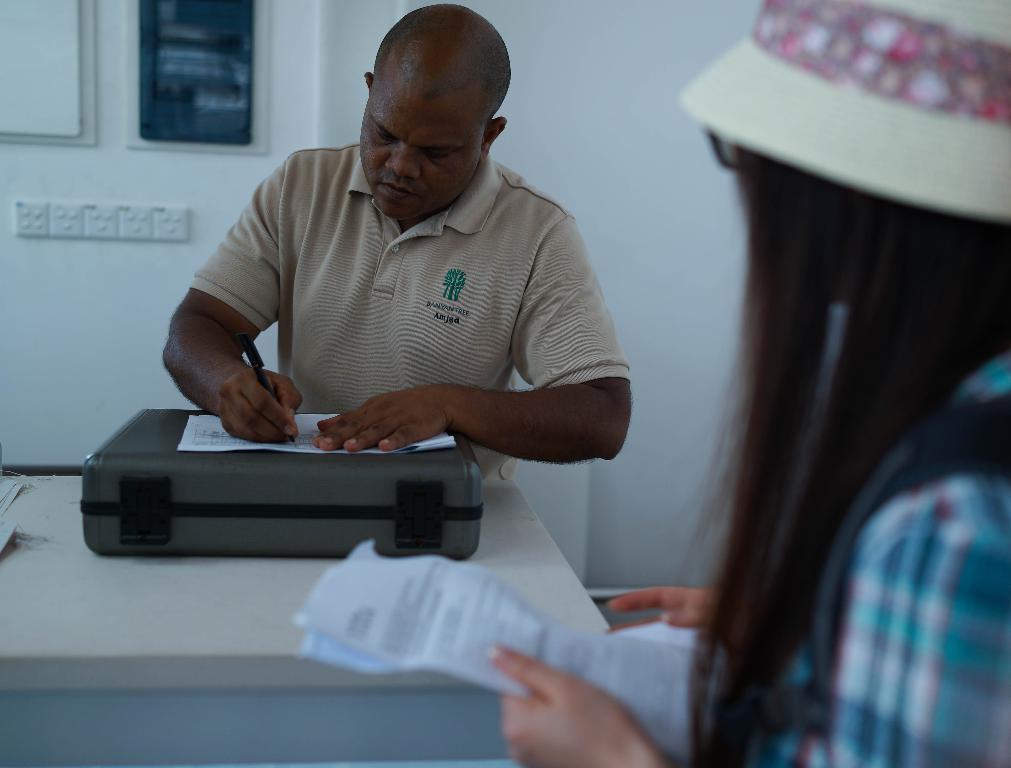In one or two sentences, can you explain what this image depicts? In this image I can see two people and one person with the hat. I can see one person holding the paper and an another person holding the pen. There is a paper, briefcase and table in-front of the person. I can see some objects to the wall. 